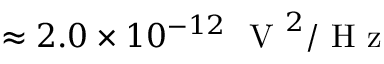<formula> <loc_0><loc_0><loc_500><loc_500>\approx 2 . 0 \times 1 0 ^ { - 1 2 } V ^ { 2 } / H z</formula> 